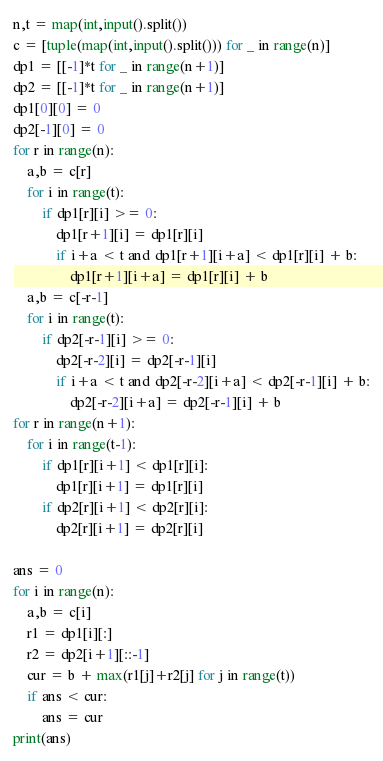Convert code to text. <code><loc_0><loc_0><loc_500><loc_500><_Python_>n,t = map(int,input().split())
c = [tuple(map(int,input().split())) for _ in range(n)]
dp1 = [[-1]*t for _ in range(n+1)]
dp2 = [[-1]*t for _ in range(n+1)]
dp1[0][0] = 0
dp2[-1][0] = 0
for r in range(n):
    a,b = c[r]
    for i in range(t):
        if dp1[r][i] >= 0:
            dp1[r+1][i] = dp1[r][i]
            if i+a < t and dp1[r+1][i+a] < dp1[r][i] + b:
                dp1[r+1][i+a] = dp1[r][i] + b
    a,b = c[-r-1]
    for i in range(t):
        if dp2[-r-1][i] >= 0:
            dp2[-r-2][i] = dp2[-r-1][i]
            if i+a < t and dp2[-r-2][i+a] < dp2[-r-1][i] + b:
                dp2[-r-2][i+a] = dp2[-r-1][i] + b
for r in range(n+1):
    for i in range(t-1):
        if dp1[r][i+1] < dp1[r][i]:
            dp1[r][i+1] = dp1[r][i]
        if dp2[r][i+1] < dp2[r][i]:
            dp2[r][i+1] = dp2[r][i]

ans = 0
for i in range(n):
    a,b = c[i]
    r1 = dp1[i][:]
    r2 = dp2[i+1][::-1] 
    cur = b + max(r1[j]+r2[j] for j in range(t))
    if ans < cur:
        ans = cur
print(ans)</code> 